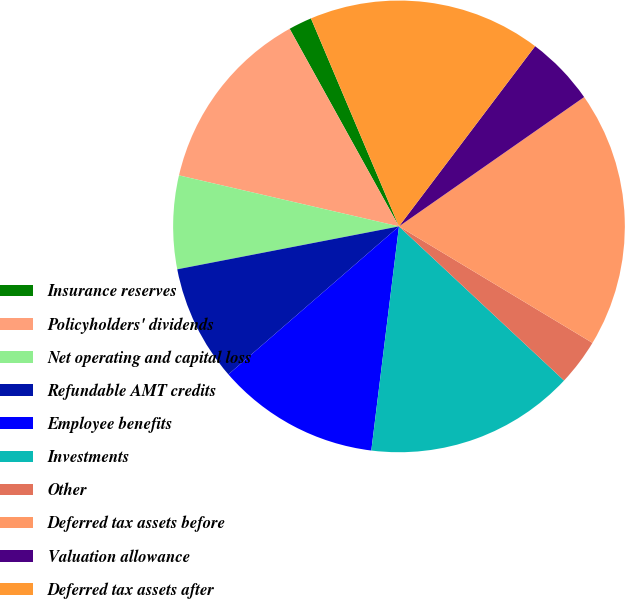Convert chart to OTSL. <chart><loc_0><loc_0><loc_500><loc_500><pie_chart><fcel>Insurance reserves<fcel>Policyholders' dividends<fcel>Net operating and capital loss<fcel>Refundable AMT credits<fcel>Employee benefits<fcel>Investments<fcel>Other<fcel>Deferred tax assets before<fcel>Valuation allowance<fcel>Deferred tax assets after<nl><fcel>1.67%<fcel>13.33%<fcel>6.67%<fcel>8.33%<fcel>11.67%<fcel>15.0%<fcel>3.33%<fcel>18.33%<fcel>5.0%<fcel>16.67%<nl></chart> 